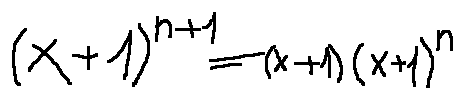<formula> <loc_0><loc_0><loc_500><loc_500>( x + 1 ) ^ { n + 1 } = ( x + 1 ) ( x + 1 ) ^ { n }</formula> 